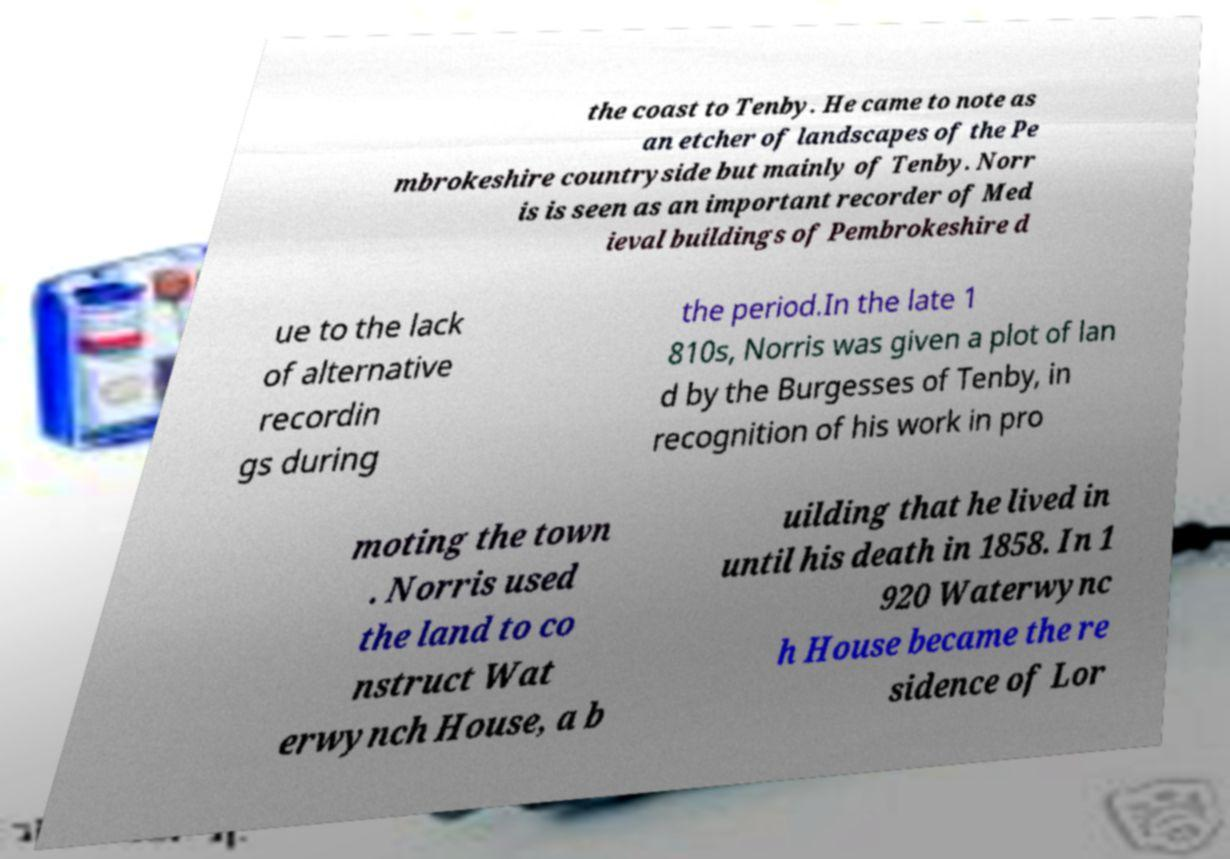I need the written content from this picture converted into text. Can you do that? the coast to Tenby. He came to note as an etcher of landscapes of the Pe mbrokeshire countryside but mainly of Tenby. Norr is is seen as an important recorder of Med ieval buildings of Pembrokeshire d ue to the lack of alternative recordin gs during the period.In the late 1 810s, Norris was given a plot of lan d by the Burgesses of Tenby, in recognition of his work in pro moting the town . Norris used the land to co nstruct Wat erwynch House, a b uilding that he lived in until his death in 1858. In 1 920 Waterwync h House became the re sidence of Lor 